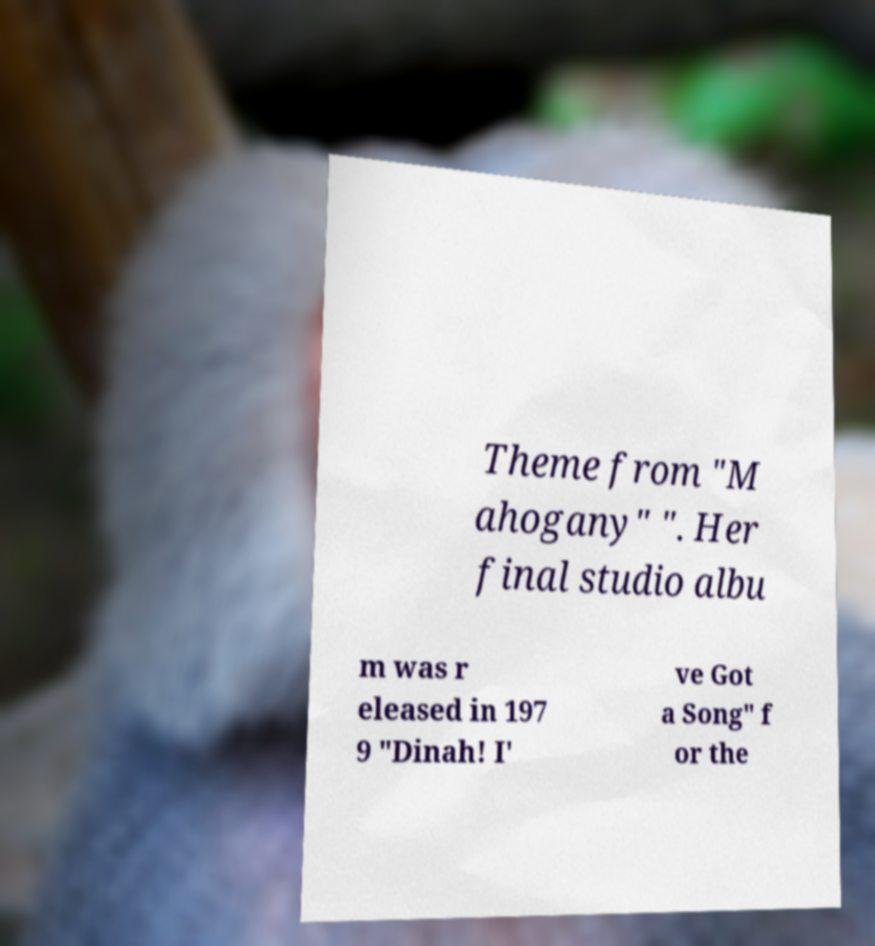Can you read and provide the text displayed in the image?This photo seems to have some interesting text. Can you extract and type it out for me? Theme from "M ahogany" ". Her final studio albu m was r eleased in 197 9 "Dinah! I' ve Got a Song" f or the 